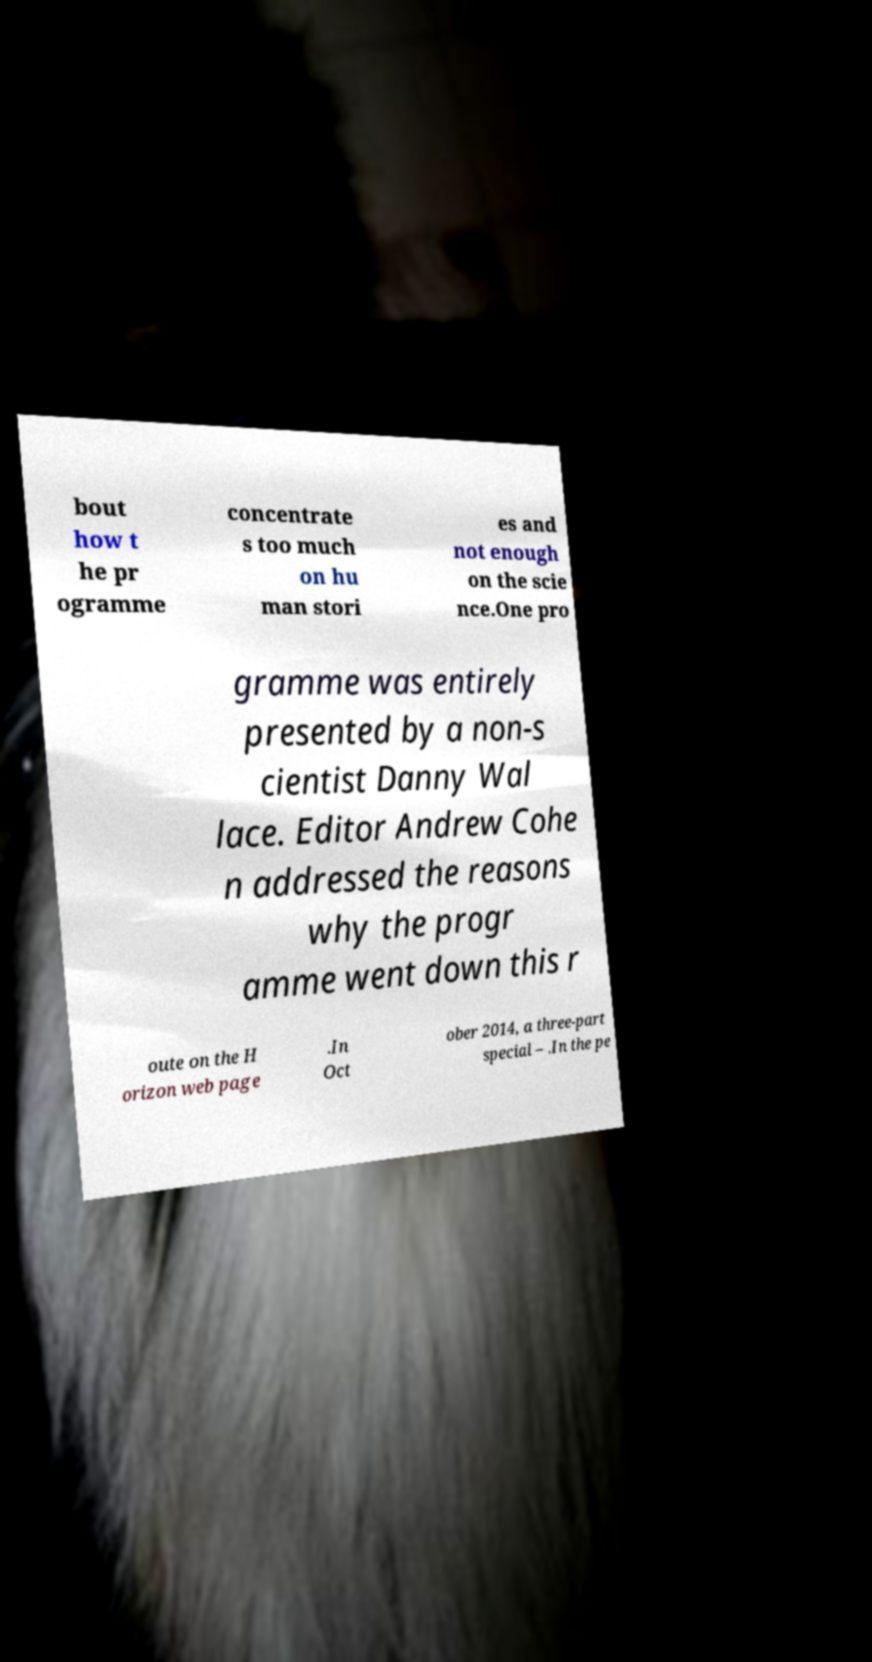Could you extract and type out the text from this image? bout how t he pr ogramme concentrate s too much on hu man stori es and not enough on the scie nce.One pro gramme was entirely presented by a non-s cientist Danny Wal lace. Editor Andrew Cohe n addressed the reasons why the progr amme went down this r oute on the H orizon web page .In Oct ober 2014, a three-part special – .In the pe 